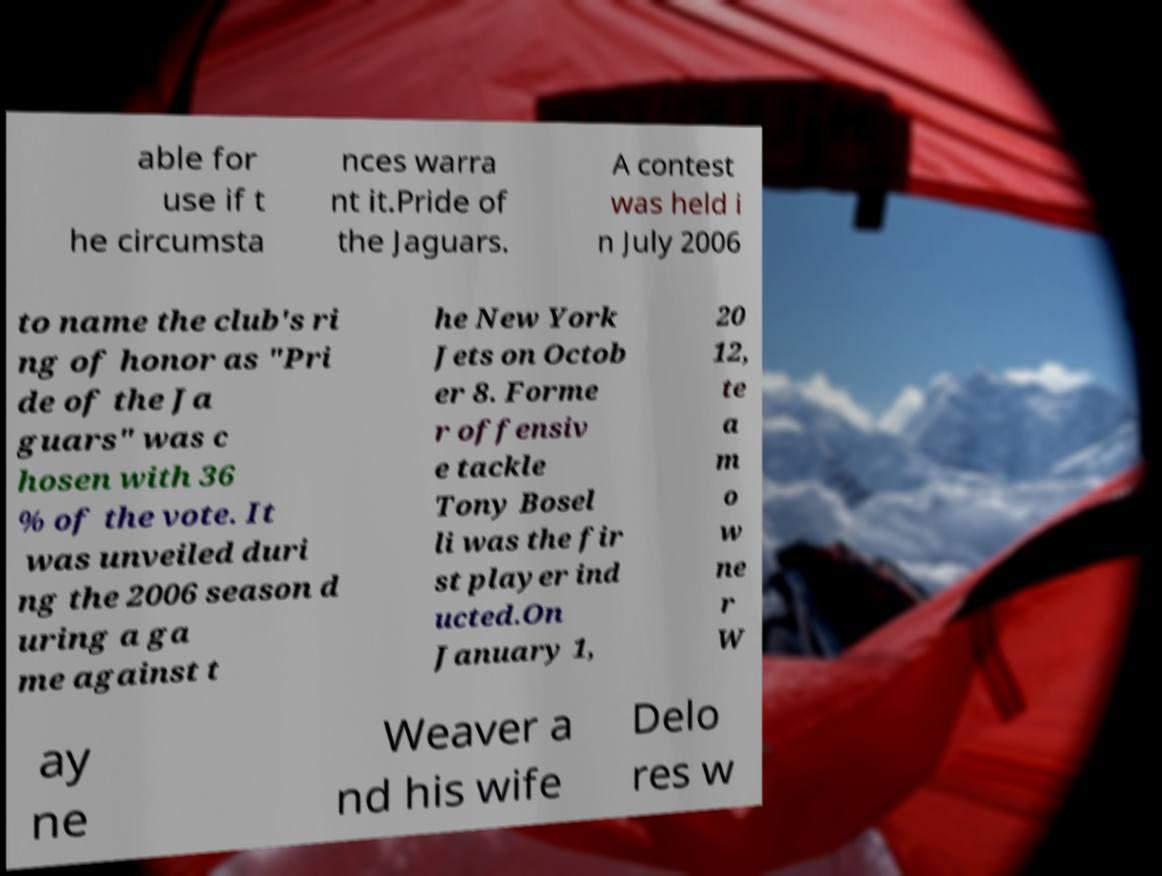There's text embedded in this image that I need extracted. Can you transcribe it verbatim? able for use if t he circumsta nces warra nt it.Pride of the Jaguars. A contest was held i n July 2006 to name the club's ri ng of honor as "Pri de of the Ja guars" was c hosen with 36 % of the vote. It was unveiled duri ng the 2006 season d uring a ga me against t he New York Jets on Octob er 8. Forme r offensiv e tackle Tony Bosel li was the fir st player ind ucted.On January 1, 20 12, te a m o w ne r W ay ne Weaver a nd his wife Delo res w 